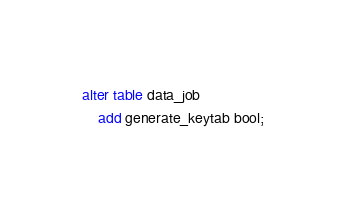<code> <loc_0><loc_0><loc_500><loc_500><_SQL_>alter table data_job
    add generate_keytab bool;
</code> 